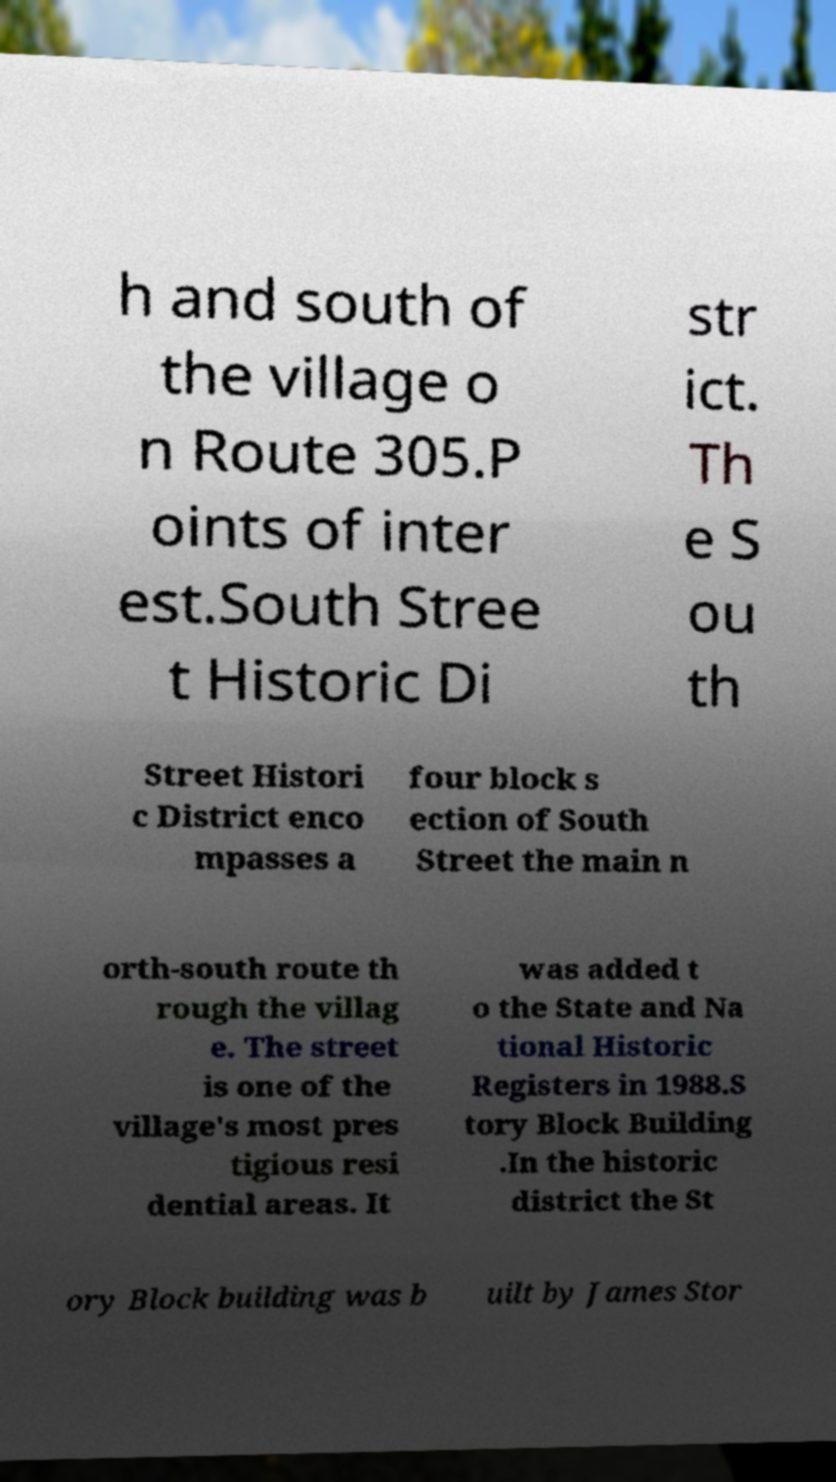There's text embedded in this image that I need extracted. Can you transcribe it verbatim? h and south of the village o n Route 305.P oints of inter est.South Stree t Historic Di str ict. Th e S ou th Street Histori c District enco mpasses a four block s ection of South Street the main n orth-south route th rough the villag e. The street is one of the village's most pres tigious resi dential areas. It was added t o the State and Na tional Historic Registers in 1988.S tory Block Building .In the historic district the St ory Block building was b uilt by James Stor 